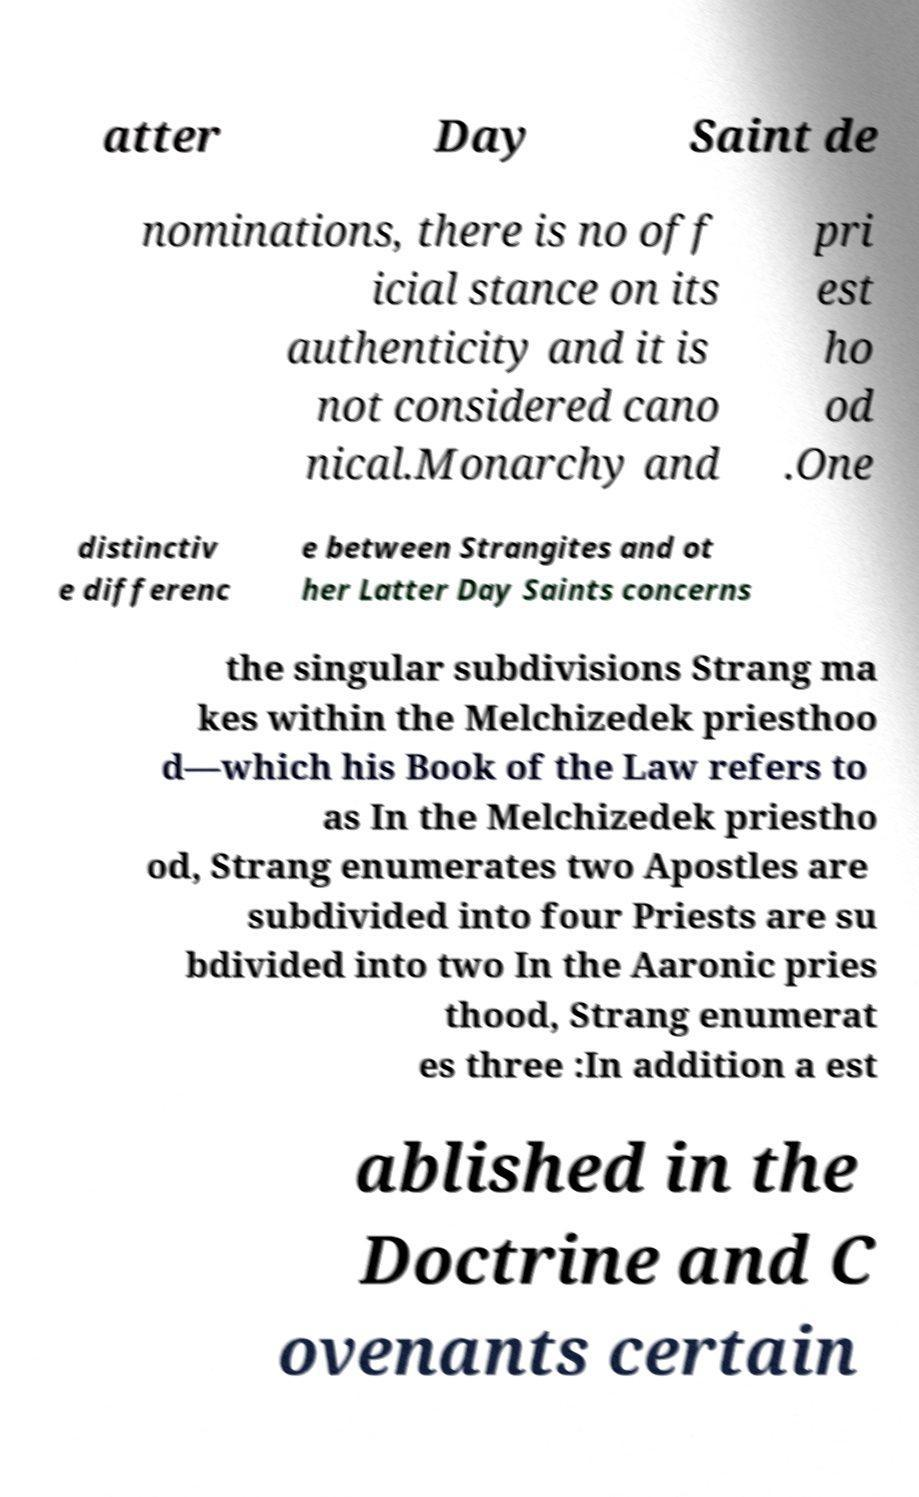Could you extract and type out the text from this image? atter Day Saint de nominations, there is no off icial stance on its authenticity and it is not considered cano nical.Monarchy and pri est ho od .One distinctiv e differenc e between Strangites and ot her Latter Day Saints concerns the singular subdivisions Strang ma kes within the Melchizedek priesthoo d—which his Book of the Law refers to as In the Melchizedek priestho od, Strang enumerates two Apostles are subdivided into four Priests are su bdivided into two In the Aaronic pries thood, Strang enumerat es three :In addition a est ablished in the Doctrine and C ovenants certain 